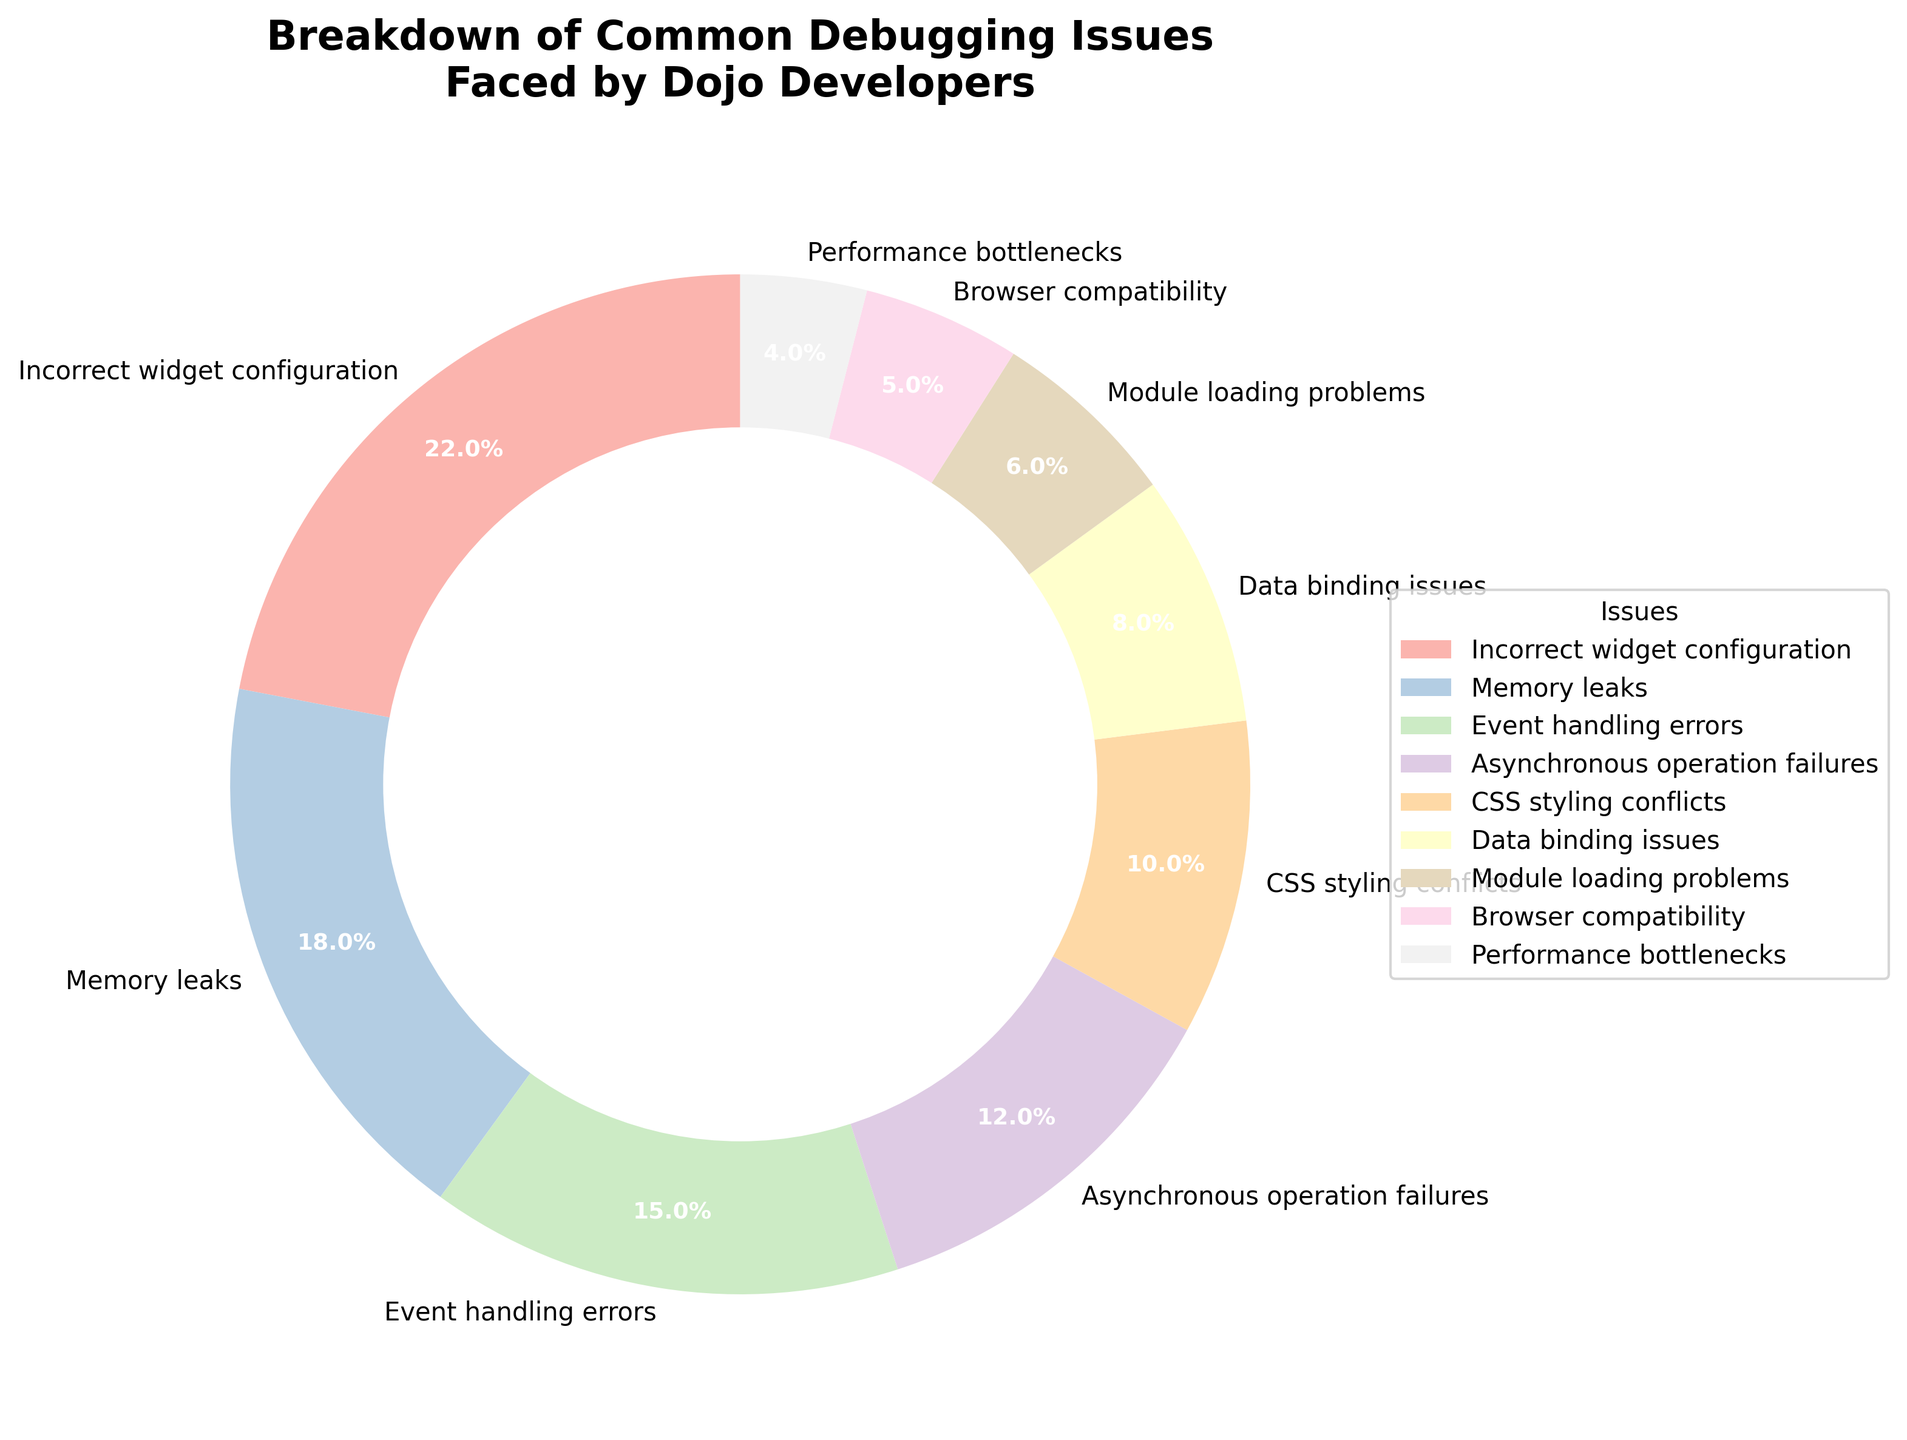What's the most common debugging issue faced by Dojo developers? The slice with the largest percentage in the pie chart represents the most common issue. From the chart, the largest slice is labeled "Incorrect widget configuration" with 22%.
Answer: Incorrect widget configuration Which issue has a higher percentage: Event handling errors or Asynchronous operation failures? To determine this, compare the percentages of the two issues. Event handling errors have 15%, while Asynchronous operation failures have 12%.
Answer: Event handling errors What is the combined percentage of Memory leaks and Performance bottlenecks? Add the percentages of both issues: Memory leaks (18%) and Performance bottlenecks (4%). The combined total is 18% + 4%.
Answer: 22% Which issue is the least common among Dojo developers? The smallest slice of the pie chart represents the least common issue. The smallest slice is labeled "Performance bottlenecks" with 4%.
Answer: Performance bottlenecks Are CSS styling conflicts more prevalent than Data binding issues, and by how much? Compare the percentages of CSS styling conflicts (10%) and Data binding issues (8%). The difference is calculated as 10% - 8%.
Answer: Yes, by 2% Which segment has a larger percentage: Browser compatibility or Module loading problems? Compare the percentages of Browser compatibility (5%) and Module loading problems (6%).
Answer: Module loading problems What is the total percentage of issues related to rendering (CSS styling conflicts and Browser compatibility)? Add the percentages of CSS styling conflicts (10%) and Browser compatibility (5%). The total is 10% + 5%.
Answer: 15% Which two issues combined account for over 30% of the total debugging issues? To determine this, find pairs of issues whose combined percentages exceed 30%. Incorrect widget configuration (22%) and any issue with a percentage of at least 8% (e.g., Memory leaks with 18%) together account for 40%.
Answer: Incorrect widget configuration and Memory leaks What's the difference in percentage between the most common issue and the least common issue? Subtract the percentage of the least common issue (Performance bottlenecks, 4%) from the most common issue (Incorrect widget configuration, 22%). The difference is 22% - 4%.
Answer: 18% 